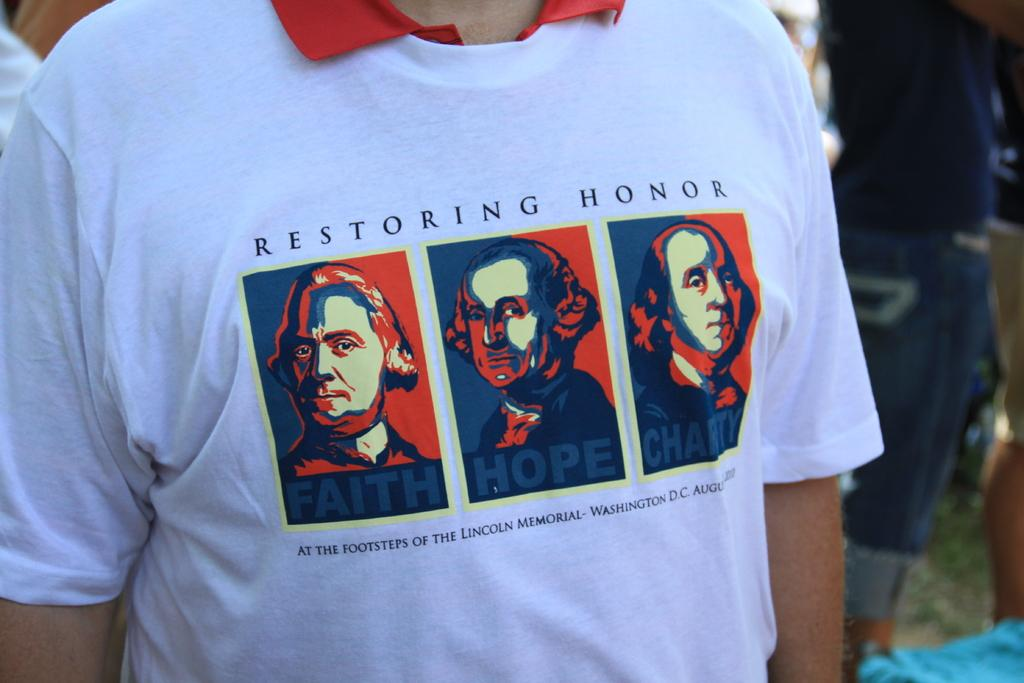What is happening in the image? There are people standing in the image. Can you describe the clothing of one of the people? A person is wearing a white t-shirt. What is depicted on the t-shirt? There is a picture of men on the t-shirt. Are there any words on the t-shirt? Yes, there is text on the t-shirt. What type of feast is being prepared by the geese in the image? There are no geese or feast preparation present in the image. Can you describe the slope of the hill in the image? There is no hill or slope present in the image. 